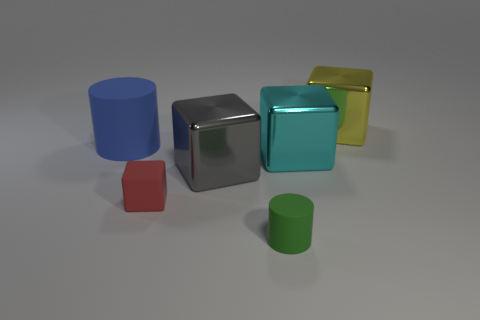There is a tiny rubber object that is behind the matte cylinder that is right of the rubber thing behind the red block; what is its color?
Provide a succinct answer. Red. Does the blue cylinder have the same material as the green object that is in front of the small red thing?
Provide a short and direct response. Yes. What material is the yellow cube?
Ensure brevity in your answer.  Metal. What number of other things are there of the same material as the blue object
Provide a short and direct response. 2. The thing that is both in front of the cyan thing and behind the red thing has what shape?
Provide a short and direct response. Cube. The cylinder that is the same material as the blue object is what color?
Ensure brevity in your answer.  Green. Are there the same number of large metal objects that are behind the large blue rubber cylinder and small brown metal cubes?
Keep it short and to the point. No. There is a red thing that is the same size as the green matte thing; what is its shape?
Keep it short and to the point. Cube. How many other objects are the same shape as the yellow metal thing?
Make the answer very short. 3. There is a gray cube; is its size the same as the matte cylinder behind the small matte cube?
Your answer should be very brief. Yes. 